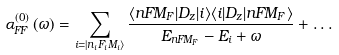<formula> <loc_0><loc_0><loc_500><loc_500>\alpha _ { F F } ^ { \left ( 0 \right ) } \left ( \omega \right ) = \sum _ { i = | n _ { i } F _ { i } M _ { i } \rangle } \frac { \langle n F M _ { F } | D _ { z } | i \rangle \langle i | D _ { z } | n F M _ { F } \rangle } { E _ { n F M _ { F } } - E _ { i } + \omega } + \dots</formula> 